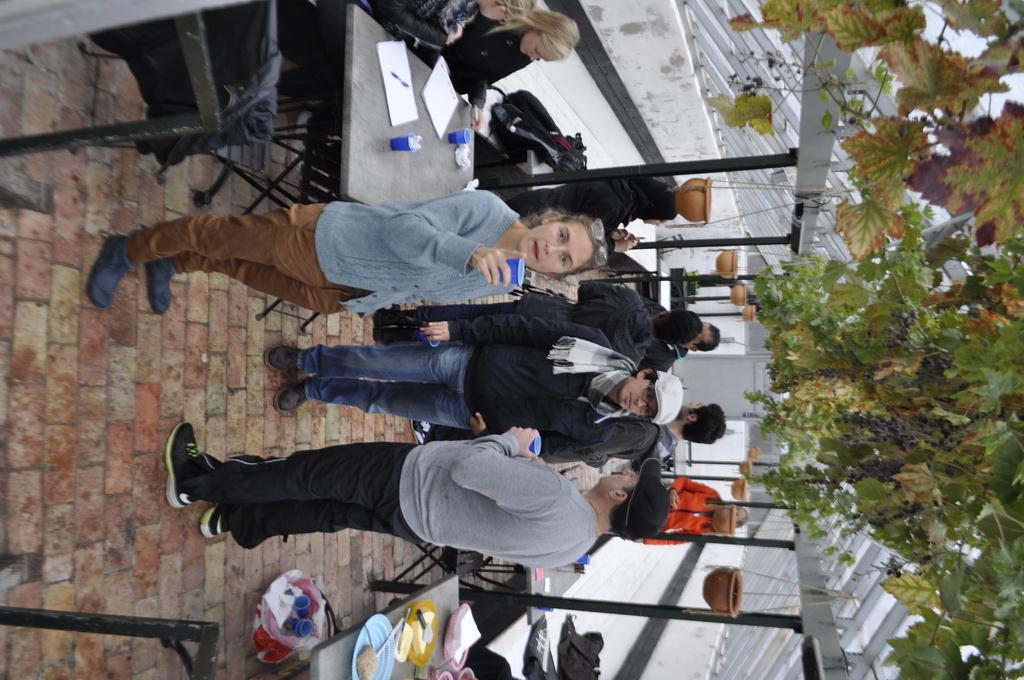Could you give a brief overview of what you see in this image? In this picture we can see persons standing on a floor and holding glasses in their hands. We can see a table and on the table there is pen, papers and glasses. We can see persons sitting on a chair. These are pots hanged to a stand. Here on the table we can see plates of food. Under the table there is a basket. At the top we can see a tree. 